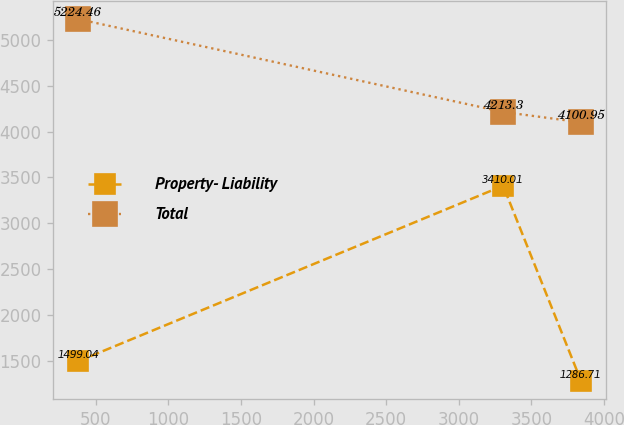Convert chart to OTSL. <chart><loc_0><loc_0><loc_500><loc_500><line_chart><ecel><fcel>Property- Liability<fcel>Total<nl><fcel>379.85<fcel>1499.04<fcel>5224.46<nl><fcel>3305.57<fcel>3410.01<fcel>4213.3<nl><fcel>3841.55<fcel>1286.71<fcel>4100.95<nl></chart> 